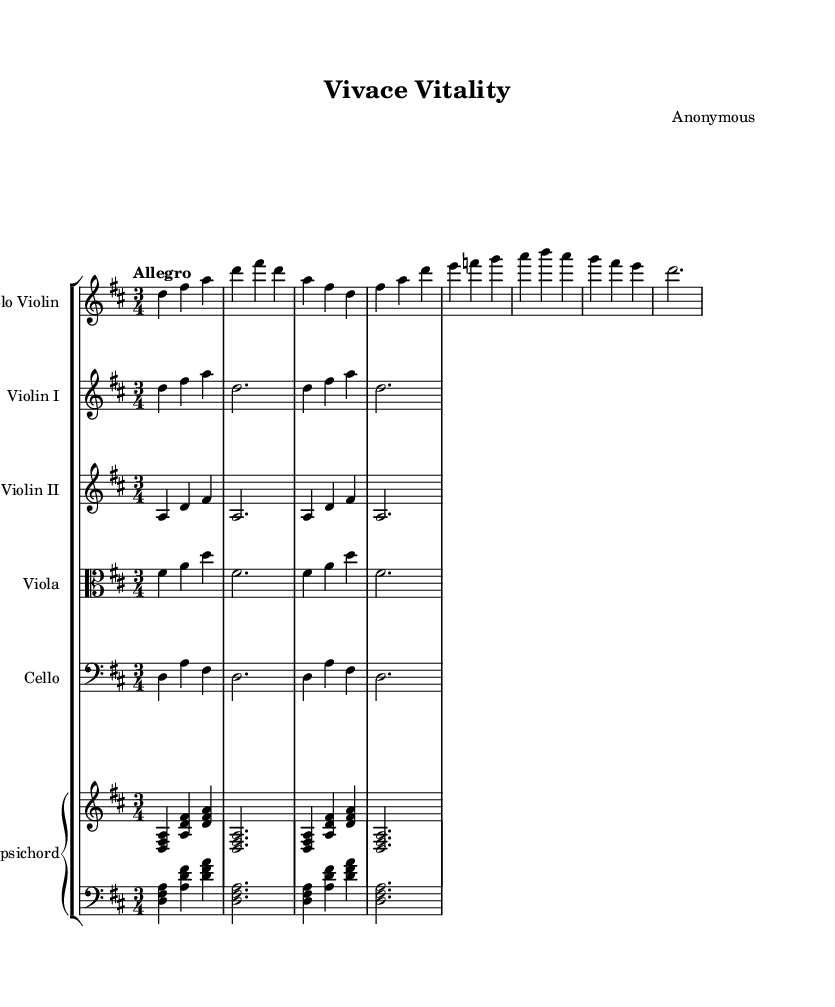What is the key signature of this music? The key signature is D major, which has two sharps (F# and C#). This is determined by identifying the key signature at the beginning of the sheet music.
Answer: D major What is the time signature of this piece? The time signature shown is 3/4, indicated at the beginning of the piece. This means there are three beats in each measure, and the quarter note gets one beat.
Answer: 3/4 What is the tempo marking for this music? The tempo marking at the top states "Allegro," which indicates a fast, lively tempo. This is found right above the key signature in the tempo indication.
Answer: Allegro How many measures does the solo violin part have? By counting the measures in the solo violin part, we find it has 8 measures. This can be done by looking at the bar lines that separate the music into measures.
Answer: 8 Which instrument has the lowest range in this piece? The cello is playing the bass part, which typically has the lowest pitch range among the instruments shown on the score. Since it is in the bass clef, it is designed for lower notes compared to the violins and viola.
Answer: Cello What type of piece is this based on its characteristics? This piece is a concerto, as inferred from the structure that typically highlights a solo instrument (the violin) alongside an ensemble, which is characteristic of Baroque concertos. Additionally, the lively tempo and instrumental arrangement support this classification.
Answer: Concerto 